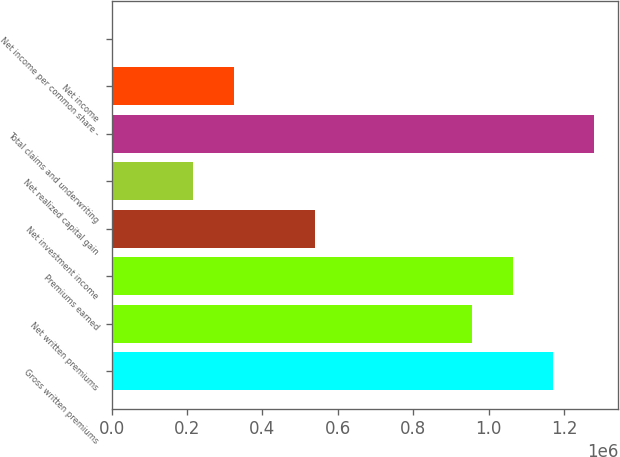<chart> <loc_0><loc_0><loc_500><loc_500><bar_chart><fcel>Gross written premiums<fcel>Net written premiums<fcel>Premiums earned<fcel>Net investment income<fcel>Net realized capital gain<fcel>Total claims and underwriting<fcel>Net income<fcel>Net income per common share -<nl><fcel>1.17155e+06<fcel>955499<fcel>1.06353e+06<fcel>540139<fcel>216056<fcel>1.27958e+06<fcel>324084<fcel>0.19<nl></chart> 